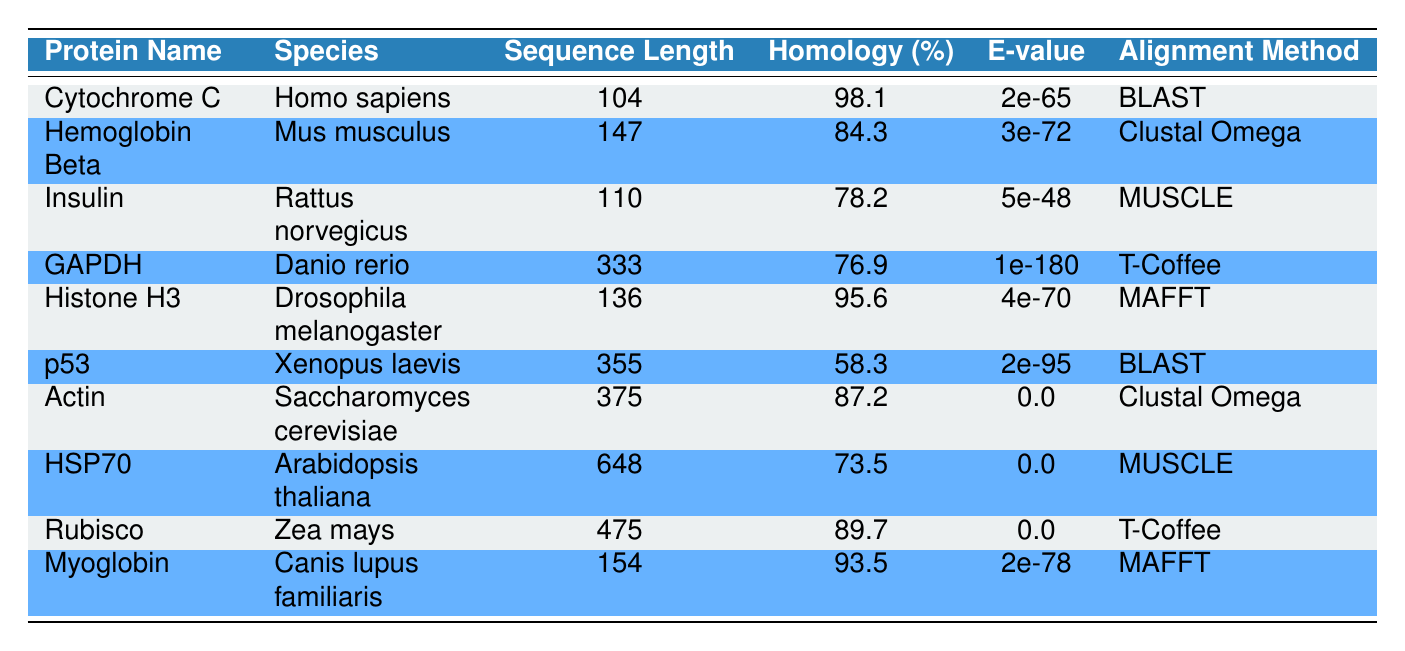What is the species of the protein with the highest homology percentage? To find the protein with the highest homology percentage, we need to scan through the "Homology (%)" column. The highest percentage is 98.1%, which corresponds to "Cytochrome C", and its species is "Homo sapiens".
Answer: Homo sapiens Which protein has the longest sequence length? Looking at the "Sequence Length" column, the longest sequence is 648, which corresponds to "HSP70" from "Arabidopsis thaliana".
Answer: HSP70 Is there a protein with an E-value of 0.0? We can check the "E-value" column to see if any protein has an E-value of 0.0. "Actin" and "HSP70" both have this E-value. Therefore, the answer is yes.
Answer: Yes What is the average homology percentage of the proteins aligned using MUSCLE? The proteins aligned using MUSCLE are "Insulin" (78.2), "HSP70" (73.5). Their sum is 151.7. There are 2 proteins, so the average is 151.7 / 2 = 75.85.
Answer: 75.85 Which protein has the lowest homology percentage and what is that percentage? Scanning through the "Homology (%)" column reveals that the lowest homology percentage is 58.3%, which corresponds to the protein "p53".
Answer: 58.3% Does Hemoglobin Beta have a higher homology percentage than Insulin? We can compare the "Homology (%)" values of both proteins. Hemoglobin Beta has 84.3% while Insulin has 78.2%. Since 84.3% is greater than 78.2%, Hemoglobin Beta does indeed have a higher percentage.
Answer: Yes How many proteins have a homology percentage greater than 90%? Checking the "Homology (%)" column, we find that "Cytochrome C" (98.1%), "Histone H3" (95.6%), and "Myoglobin" (93.5%) exceed 90%. This totals to three proteins.
Answer: 3 Which alignment method is used for the protein with the second highest sequence length? First, identify the second longest sequence length which is 475 for "Rubisco". The corresponding alignment method is "T-Coffee".
Answer: T-Coffee What is the difference in sequence lengths between Actin and Insulin? The sequence lengths for Actin and Insulin are 375 and 110, respectively. The difference is 375 - 110 = 265.
Answer: 265 